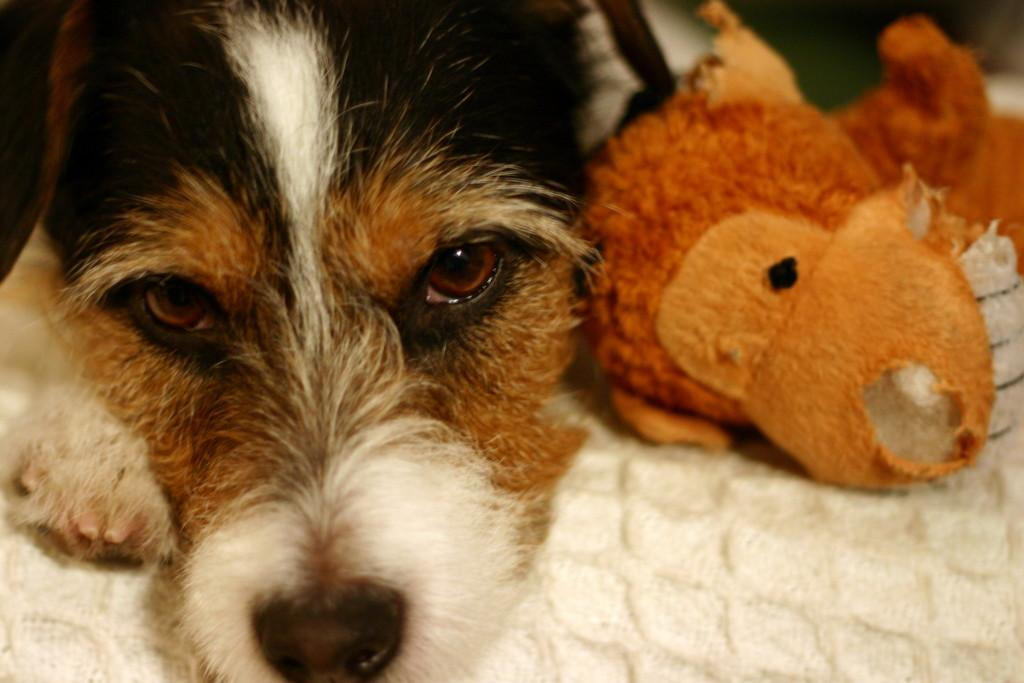What type of animal is present in the image? There is a dog in the image. What other object can be seen in the image? There is a toy in the image. What color is the surface the dog and toy are on? The surface the dog and toy are on is white. How would you describe the background of the image? The background of the image is blurred. Can you tell me how many chickens are playing with the dog in the image? There are no chickens present in the image; it features a dog and a toy on a white surface with a blurred background. 